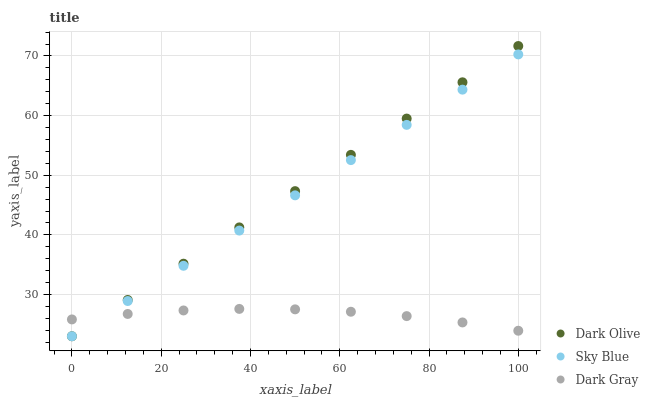Does Dark Gray have the minimum area under the curve?
Answer yes or no. Yes. Does Dark Olive have the maximum area under the curve?
Answer yes or no. Yes. Does Sky Blue have the minimum area under the curve?
Answer yes or no. No. Does Sky Blue have the maximum area under the curve?
Answer yes or no. No. Is Dark Olive the smoothest?
Answer yes or no. Yes. Is Dark Gray the roughest?
Answer yes or no. Yes. Is Sky Blue the smoothest?
Answer yes or no. No. Is Sky Blue the roughest?
Answer yes or no. No. Does Sky Blue have the lowest value?
Answer yes or no. Yes. Does Dark Olive have the highest value?
Answer yes or no. Yes. Does Sky Blue have the highest value?
Answer yes or no. No. Does Sky Blue intersect Dark Olive?
Answer yes or no. Yes. Is Sky Blue less than Dark Olive?
Answer yes or no. No. Is Sky Blue greater than Dark Olive?
Answer yes or no. No. 